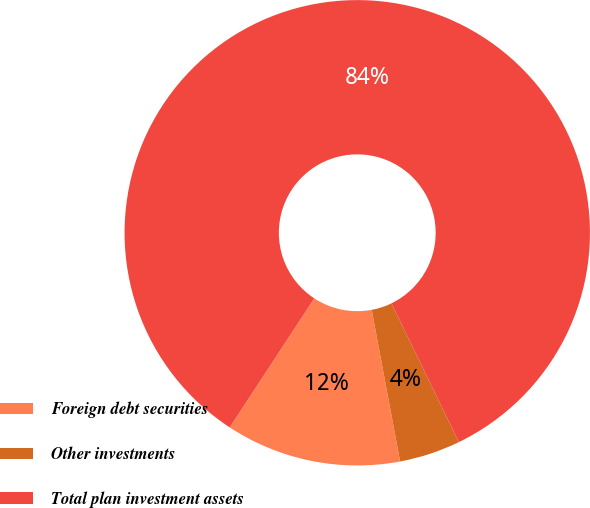Convert chart to OTSL. <chart><loc_0><loc_0><loc_500><loc_500><pie_chart><fcel>Foreign debt securities<fcel>Other investments<fcel>Total plan investment assets<nl><fcel>12.18%<fcel>4.24%<fcel>83.58%<nl></chart> 